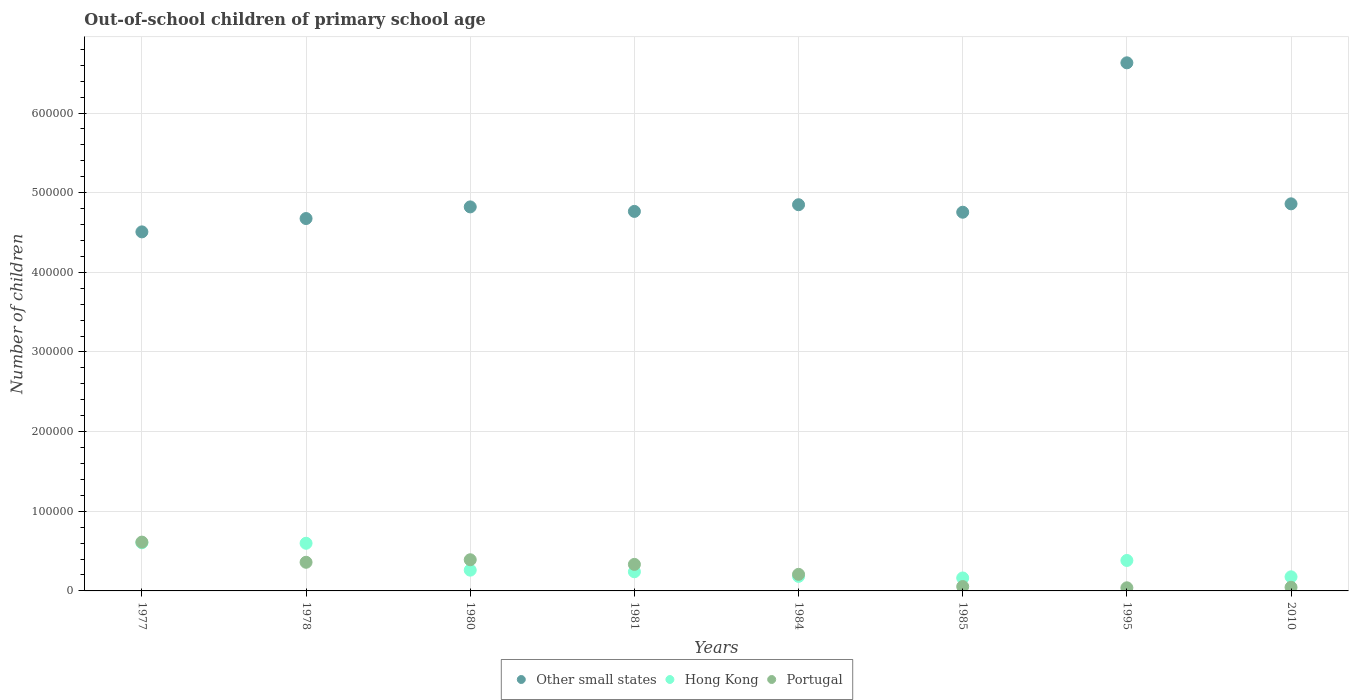What is the number of out-of-school children in Other small states in 1995?
Provide a short and direct response. 6.63e+05. Across all years, what is the maximum number of out-of-school children in Other small states?
Your response must be concise. 6.63e+05. Across all years, what is the minimum number of out-of-school children in Hong Kong?
Keep it short and to the point. 1.63e+04. In which year was the number of out-of-school children in Portugal maximum?
Your answer should be very brief. 1977. In which year was the number of out-of-school children in Hong Kong minimum?
Offer a very short reply. 1985. What is the total number of out-of-school children in Other small states in the graph?
Your answer should be compact. 3.99e+06. What is the difference between the number of out-of-school children in Portugal in 1977 and that in 1995?
Your response must be concise. 5.74e+04. What is the difference between the number of out-of-school children in Other small states in 1984 and the number of out-of-school children in Portugal in 1978?
Your answer should be very brief. 4.49e+05. What is the average number of out-of-school children in Portugal per year?
Provide a succinct answer. 2.56e+04. In the year 1977, what is the difference between the number of out-of-school children in Hong Kong and number of out-of-school children in Other small states?
Your answer should be very brief. -3.90e+05. What is the ratio of the number of out-of-school children in Portugal in 1984 to that in 2010?
Give a very brief answer. 4.57. What is the difference between the highest and the second highest number of out-of-school children in Other small states?
Offer a very short reply. 1.77e+05. What is the difference between the highest and the lowest number of out-of-school children in Other small states?
Ensure brevity in your answer.  2.12e+05. In how many years, is the number of out-of-school children in Other small states greater than the average number of out-of-school children in Other small states taken over all years?
Your response must be concise. 1. Is the sum of the number of out-of-school children in Other small states in 1978 and 1984 greater than the maximum number of out-of-school children in Hong Kong across all years?
Your response must be concise. Yes. Does the number of out-of-school children in Portugal monotonically increase over the years?
Give a very brief answer. No. Is the number of out-of-school children in Portugal strictly greater than the number of out-of-school children in Other small states over the years?
Offer a very short reply. No. Are the values on the major ticks of Y-axis written in scientific E-notation?
Give a very brief answer. No. Does the graph contain any zero values?
Ensure brevity in your answer.  No. Does the graph contain grids?
Your response must be concise. Yes. Where does the legend appear in the graph?
Offer a very short reply. Bottom center. What is the title of the graph?
Keep it short and to the point. Out-of-school children of primary school age. Does "Small states" appear as one of the legend labels in the graph?
Your answer should be very brief. No. What is the label or title of the X-axis?
Ensure brevity in your answer.  Years. What is the label or title of the Y-axis?
Your response must be concise. Number of children. What is the Number of children of Other small states in 1977?
Your answer should be very brief. 4.51e+05. What is the Number of children of Hong Kong in 1977?
Your answer should be very brief. 6.05e+04. What is the Number of children in Portugal in 1977?
Ensure brevity in your answer.  6.13e+04. What is the Number of children of Other small states in 1978?
Give a very brief answer. 4.68e+05. What is the Number of children in Hong Kong in 1978?
Provide a short and direct response. 5.98e+04. What is the Number of children of Portugal in 1978?
Ensure brevity in your answer.  3.60e+04. What is the Number of children in Other small states in 1980?
Your answer should be compact. 4.82e+05. What is the Number of children of Hong Kong in 1980?
Your response must be concise. 2.61e+04. What is the Number of children of Portugal in 1980?
Your response must be concise. 3.91e+04. What is the Number of children in Other small states in 1981?
Your answer should be very brief. 4.77e+05. What is the Number of children of Hong Kong in 1981?
Ensure brevity in your answer.  2.41e+04. What is the Number of children of Portugal in 1981?
Provide a short and direct response. 3.33e+04. What is the Number of children of Other small states in 1984?
Offer a terse response. 4.85e+05. What is the Number of children of Hong Kong in 1984?
Offer a terse response. 1.83e+04. What is the Number of children of Portugal in 1984?
Offer a very short reply. 2.08e+04. What is the Number of children in Other small states in 1985?
Make the answer very short. 4.75e+05. What is the Number of children of Hong Kong in 1985?
Offer a very short reply. 1.63e+04. What is the Number of children in Portugal in 1985?
Your answer should be very brief. 5480. What is the Number of children in Other small states in 1995?
Provide a short and direct response. 6.63e+05. What is the Number of children of Hong Kong in 1995?
Your answer should be compact. 3.82e+04. What is the Number of children of Portugal in 1995?
Make the answer very short. 3909. What is the Number of children of Other small states in 2010?
Your answer should be compact. 4.86e+05. What is the Number of children of Hong Kong in 2010?
Keep it short and to the point. 1.77e+04. What is the Number of children in Portugal in 2010?
Give a very brief answer. 4556. Across all years, what is the maximum Number of children of Other small states?
Ensure brevity in your answer.  6.63e+05. Across all years, what is the maximum Number of children of Hong Kong?
Provide a succinct answer. 6.05e+04. Across all years, what is the maximum Number of children of Portugal?
Provide a succinct answer. 6.13e+04. Across all years, what is the minimum Number of children in Other small states?
Your response must be concise. 4.51e+05. Across all years, what is the minimum Number of children in Hong Kong?
Offer a very short reply. 1.63e+04. Across all years, what is the minimum Number of children in Portugal?
Ensure brevity in your answer.  3909. What is the total Number of children of Other small states in the graph?
Provide a succinct answer. 3.99e+06. What is the total Number of children in Hong Kong in the graph?
Ensure brevity in your answer.  2.61e+05. What is the total Number of children of Portugal in the graph?
Your answer should be compact. 2.04e+05. What is the difference between the Number of children in Other small states in 1977 and that in 1978?
Offer a terse response. -1.68e+04. What is the difference between the Number of children in Hong Kong in 1977 and that in 1978?
Offer a very short reply. 634. What is the difference between the Number of children in Portugal in 1977 and that in 1978?
Your answer should be very brief. 2.53e+04. What is the difference between the Number of children in Other small states in 1977 and that in 1980?
Your answer should be compact. -3.14e+04. What is the difference between the Number of children of Hong Kong in 1977 and that in 1980?
Your answer should be compact. 3.44e+04. What is the difference between the Number of children in Portugal in 1977 and that in 1980?
Provide a short and direct response. 2.21e+04. What is the difference between the Number of children of Other small states in 1977 and that in 1981?
Provide a succinct answer. -2.57e+04. What is the difference between the Number of children in Hong Kong in 1977 and that in 1981?
Provide a short and direct response. 3.64e+04. What is the difference between the Number of children in Portugal in 1977 and that in 1981?
Keep it short and to the point. 2.80e+04. What is the difference between the Number of children in Other small states in 1977 and that in 1984?
Ensure brevity in your answer.  -3.41e+04. What is the difference between the Number of children in Hong Kong in 1977 and that in 1984?
Provide a short and direct response. 4.22e+04. What is the difference between the Number of children of Portugal in 1977 and that in 1984?
Offer a terse response. 4.05e+04. What is the difference between the Number of children in Other small states in 1977 and that in 1985?
Ensure brevity in your answer.  -2.47e+04. What is the difference between the Number of children in Hong Kong in 1977 and that in 1985?
Offer a terse response. 4.42e+04. What is the difference between the Number of children of Portugal in 1977 and that in 1985?
Offer a very short reply. 5.58e+04. What is the difference between the Number of children of Other small states in 1977 and that in 1995?
Provide a succinct answer. -2.12e+05. What is the difference between the Number of children in Hong Kong in 1977 and that in 1995?
Provide a short and direct response. 2.22e+04. What is the difference between the Number of children in Portugal in 1977 and that in 1995?
Ensure brevity in your answer.  5.74e+04. What is the difference between the Number of children of Other small states in 1977 and that in 2010?
Offer a very short reply. -3.52e+04. What is the difference between the Number of children in Hong Kong in 1977 and that in 2010?
Make the answer very short. 4.28e+04. What is the difference between the Number of children of Portugal in 1977 and that in 2010?
Your answer should be very brief. 5.67e+04. What is the difference between the Number of children in Other small states in 1978 and that in 1980?
Keep it short and to the point. -1.46e+04. What is the difference between the Number of children of Hong Kong in 1978 and that in 1980?
Provide a succinct answer. 3.38e+04. What is the difference between the Number of children of Portugal in 1978 and that in 1980?
Give a very brief answer. -3169. What is the difference between the Number of children in Other small states in 1978 and that in 1981?
Make the answer very short. -8960. What is the difference between the Number of children of Hong Kong in 1978 and that in 1981?
Your answer should be very brief. 3.58e+04. What is the difference between the Number of children in Portugal in 1978 and that in 1981?
Your answer should be compact. 2660. What is the difference between the Number of children of Other small states in 1978 and that in 1984?
Provide a short and direct response. -1.73e+04. What is the difference between the Number of children of Hong Kong in 1978 and that in 1984?
Provide a short and direct response. 4.16e+04. What is the difference between the Number of children of Portugal in 1978 and that in 1984?
Make the answer very short. 1.52e+04. What is the difference between the Number of children of Other small states in 1978 and that in 1985?
Your answer should be very brief. -7924. What is the difference between the Number of children of Hong Kong in 1978 and that in 1985?
Your answer should be compact. 4.36e+04. What is the difference between the Number of children in Portugal in 1978 and that in 1985?
Your answer should be compact. 3.05e+04. What is the difference between the Number of children in Other small states in 1978 and that in 1995?
Ensure brevity in your answer.  -1.96e+05. What is the difference between the Number of children of Hong Kong in 1978 and that in 1995?
Offer a terse response. 2.16e+04. What is the difference between the Number of children in Portugal in 1978 and that in 1995?
Your answer should be compact. 3.21e+04. What is the difference between the Number of children of Other small states in 1978 and that in 2010?
Make the answer very short. -1.85e+04. What is the difference between the Number of children of Hong Kong in 1978 and that in 2010?
Offer a very short reply. 4.21e+04. What is the difference between the Number of children of Portugal in 1978 and that in 2010?
Ensure brevity in your answer.  3.14e+04. What is the difference between the Number of children of Other small states in 1980 and that in 1981?
Offer a very short reply. 5654. What is the difference between the Number of children in Hong Kong in 1980 and that in 1981?
Provide a succinct answer. 2023. What is the difference between the Number of children in Portugal in 1980 and that in 1981?
Your answer should be compact. 5829. What is the difference between the Number of children of Other small states in 1980 and that in 1984?
Keep it short and to the point. -2719. What is the difference between the Number of children in Hong Kong in 1980 and that in 1984?
Keep it short and to the point. 7804. What is the difference between the Number of children in Portugal in 1980 and that in 1984?
Offer a terse response. 1.83e+04. What is the difference between the Number of children of Other small states in 1980 and that in 1985?
Your answer should be very brief. 6690. What is the difference between the Number of children of Hong Kong in 1980 and that in 1985?
Your answer should be compact. 9809. What is the difference between the Number of children in Portugal in 1980 and that in 1985?
Your answer should be compact. 3.37e+04. What is the difference between the Number of children in Other small states in 1980 and that in 1995?
Make the answer very short. -1.81e+05. What is the difference between the Number of children in Hong Kong in 1980 and that in 1995?
Keep it short and to the point. -1.22e+04. What is the difference between the Number of children of Portugal in 1980 and that in 1995?
Your answer should be compact. 3.52e+04. What is the difference between the Number of children in Other small states in 1980 and that in 2010?
Offer a terse response. -3837. What is the difference between the Number of children of Hong Kong in 1980 and that in 2010?
Give a very brief answer. 8370. What is the difference between the Number of children of Portugal in 1980 and that in 2010?
Provide a succinct answer. 3.46e+04. What is the difference between the Number of children in Other small states in 1981 and that in 1984?
Offer a terse response. -8373. What is the difference between the Number of children of Hong Kong in 1981 and that in 1984?
Your response must be concise. 5781. What is the difference between the Number of children of Portugal in 1981 and that in 1984?
Your answer should be compact. 1.25e+04. What is the difference between the Number of children in Other small states in 1981 and that in 1985?
Your response must be concise. 1036. What is the difference between the Number of children of Hong Kong in 1981 and that in 1985?
Provide a short and direct response. 7786. What is the difference between the Number of children in Portugal in 1981 and that in 1985?
Provide a short and direct response. 2.78e+04. What is the difference between the Number of children of Other small states in 1981 and that in 1995?
Ensure brevity in your answer.  -1.87e+05. What is the difference between the Number of children of Hong Kong in 1981 and that in 1995?
Offer a terse response. -1.42e+04. What is the difference between the Number of children in Portugal in 1981 and that in 1995?
Provide a succinct answer. 2.94e+04. What is the difference between the Number of children of Other small states in 1981 and that in 2010?
Ensure brevity in your answer.  -9491. What is the difference between the Number of children in Hong Kong in 1981 and that in 2010?
Your response must be concise. 6347. What is the difference between the Number of children of Portugal in 1981 and that in 2010?
Offer a terse response. 2.87e+04. What is the difference between the Number of children in Other small states in 1984 and that in 1985?
Your answer should be very brief. 9409. What is the difference between the Number of children in Hong Kong in 1984 and that in 1985?
Offer a very short reply. 2005. What is the difference between the Number of children in Portugal in 1984 and that in 1985?
Provide a short and direct response. 1.53e+04. What is the difference between the Number of children of Other small states in 1984 and that in 1995?
Provide a short and direct response. -1.78e+05. What is the difference between the Number of children in Hong Kong in 1984 and that in 1995?
Ensure brevity in your answer.  -2.00e+04. What is the difference between the Number of children of Portugal in 1984 and that in 1995?
Provide a succinct answer. 1.69e+04. What is the difference between the Number of children in Other small states in 1984 and that in 2010?
Provide a short and direct response. -1118. What is the difference between the Number of children in Hong Kong in 1984 and that in 2010?
Your response must be concise. 566. What is the difference between the Number of children in Portugal in 1984 and that in 2010?
Ensure brevity in your answer.  1.63e+04. What is the difference between the Number of children in Other small states in 1985 and that in 1995?
Make the answer very short. -1.88e+05. What is the difference between the Number of children in Hong Kong in 1985 and that in 1995?
Ensure brevity in your answer.  -2.20e+04. What is the difference between the Number of children of Portugal in 1985 and that in 1995?
Offer a very short reply. 1571. What is the difference between the Number of children in Other small states in 1985 and that in 2010?
Ensure brevity in your answer.  -1.05e+04. What is the difference between the Number of children of Hong Kong in 1985 and that in 2010?
Provide a succinct answer. -1439. What is the difference between the Number of children in Portugal in 1985 and that in 2010?
Your answer should be very brief. 924. What is the difference between the Number of children of Other small states in 1995 and that in 2010?
Your answer should be very brief. 1.77e+05. What is the difference between the Number of children of Hong Kong in 1995 and that in 2010?
Ensure brevity in your answer.  2.05e+04. What is the difference between the Number of children in Portugal in 1995 and that in 2010?
Your response must be concise. -647. What is the difference between the Number of children of Other small states in 1977 and the Number of children of Hong Kong in 1978?
Keep it short and to the point. 3.91e+05. What is the difference between the Number of children of Other small states in 1977 and the Number of children of Portugal in 1978?
Ensure brevity in your answer.  4.15e+05. What is the difference between the Number of children in Hong Kong in 1977 and the Number of children in Portugal in 1978?
Your answer should be very brief. 2.45e+04. What is the difference between the Number of children in Other small states in 1977 and the Number of children in Hong Kong in 1980?
Ensure brevity in your answer.  4.25e+05. What is the difference between the Number of children in Other small states in 1977 and the Number of children in Portugal in 1980?
Offer a very short reply. 4.12e+05. What is the difference between the Number of children of Hong Kong in 1977 and the Number of children of Portugal in 1980?
Offer a very short reply. 2.13e+04. What is the difference between the Number of children in Other small states in 1977 and the Number of children in Hong Kong in 1981?
Offer a terse response. 4.27e+05. What is the difference between the Number of children of Other small states in 1977 and the Number of children of Portugal in 1981?
Give a very brief answer. 4.17e+05. What is the difference between the Number of children of Hong Kong in 1977 and the Number of children of Portugal in 1981?
Give a very brief answer. 2.72e+04. What is the difference between the Number of children of Other small states in 1977 and the Number of children of Hong Kong in 1984?
Keep it short and to the point. 4.33e+05. What is the difference between the Number of children in Other small states in 1977 and the Number of children in Portugal in 1984?
Make the answer very short. 4.30e+05. What is the difference between the Number of children in Hong Kong in 1977 and the Number of children in Portugal in 1984?
Your answer should be very brief. 3.96e+04. What is the difference between the Number of children in Other small states in 1977 and the Number of children in Hong Kong in 1985?
Offer a terse response. 4.35e+05. What is the difference between the Number of children of Other small states in 1977 and the Number of children of Portugal in 1985?
Give a very brief answer. 4.45e+05. What is the difference between the Number of children in Hong Kong in 1977 and the Number of children in Portugal in 1985?
Make the answer very short. 5.50e+04. What is the difference between the Number of children of Other small states in 1977 and the Number of children of Hong Kong in 1995?
Ensure brevity in your answer.  4.13e+05. What is the difference between the Number of children in Other small states in 1977 and the Number of children in Portugal in 1995?
Give a very brief answer. 4.47e+05. What is the difference between the Number of children in Hong Kong in 1977 and the Number of children in Portugal in 1995?
Your response must be concise. 5.66e+04. What is the difference between the Number of children in Other small states in 1977 and the Number of children in Hong Kong in 2010?
Offer a terse response. 4.33e+05. What is the difference between the Number of children in Other small states in 1977 and the Number of children in Portugal in 2010?
Offer a terse response. 4.46e+05. What is the difference between the Number of children in Hong Kong in 1977 and the Number of children in Portugal in 2010?
Your answer should be compact. 5.59e+04. What is the difference between the Number of children of Other small states in 1978 and the Number of children of Hong Kong in 1980?
Your answer should be compact. 4.41e+05. What is the difference between the Number of children of Other small states in 1978 and the Number of children of Portugal in 1980?
Ensure brevity in your answer.  4.28e+05. What is the difference between the Number of children of Hong Kong in 1978 and the Number of children of Portugal in 1980?
Offer a terse response. 2.07e+04. What is the difference between the Number of children in Other small states in 1978 and the Number of children in Hong Kong in 1981?
Keep it short and to the point. 4.43e+05. What is the difference between the Number of children of Other small states in 1978 and the Number of children of Portugal in 1981?
Keep it short and to the point. 4.34e+05. What is the difference between the Number of children of Hong Kong in 1978 and the Number of children of Portugal in 1981?
Make the answer very short. 2.65e+04. What is the difference between the Number of children in Other small states in 1978 and the Number of children in Hong Kong in 1984?
Your response must be concise. 4.49e+05. What is the difference between the Number of children of Other small states in 1978 and the Number of children of Portugal in 1984?
Make the answer very short. 4.47e+05. What is the difference between the Number of children in Hong Kong in 1978 and the Number of children in Portugal in 1984?
Your response must be concise. 3.90e+04. What is the difference between the Number of children of Other small states in 1978 and the Number of children of Hong Kong in 1985?
Your answer should be very brief. 4.51e+05. What is the difference between the Number of children in Other small states in 1978 and the Number of children in Portugal in 1985?
Provide a succinct answer. 4.62e+05. What is the difference between the Number of children in Hong Kong in 1978 and the Number of children in Portugal in 1985?
Provide a succinct answer. 5.43e+04. What is the difference between the Number of children in Other small states in 1978 and the Number of children in Hong Kong in 1995?
Offer a very short reply. 4.29e+05. What is the difference between the Number of children in Other small states in 1978 and the Number of children in Portugal in 1995?
Offer a terse response. 4.64e+05. What is the difference between the Number of children of Hong Kong in 1978 and the Number of children of Portugal in 1995?
Your answer should be compact. 5.59e+04. What is the difference between the Number of children in Other small states in 1978 and the Number of children in Hong Kong in 2010?
Your response must be concise. 4.50e+05. What is the difference between the Number of children of Other small states in 1978 and the Number of children of Portugal in 2010?
Make the answer very short. 4.63e+05. What is the difference between the Number of children of Hong Kong in 1978 and the Number of children of Portugal in 2010?
Offer a very short reply. 5.53e+04. What is the difference between the Number of children in Other small states in 1980 and the Number of children in Hong Kong in 1981?
Your answer should be very brief. 4.58e+05. What is the difference between the Number of children of Other small states in 1980 and the Number of children of Portugal in 1981?
Your answer should be very brief. 4.49e+05. What is the difference between the Number of children of Hong Kong in 1980 and the Number of children of Portugal in 1981?
Ensure brevity in your answer.  -7230. What is the difference between the Number of children in Other small states in 1980 and the Number of children in Hong Kong in 1984?
Give a very brief answer. 4.64e+05. What is the difference between the Number of children in Other small states in 1980 and the Number of children in Portugal in 1984?
Provide a short and direct response. 4.61e+05. What is the difference between the Number of children in Hong Kong in 1980 and the Number of children in Portugal in 1984?
Provide a succinct answer. 5264. What is the difference between the Number of children of Other small states in 1980 and the Number of children of Hong Kong in 1985?
Offer a terse response. 4.66e+05. What is the difference between the Number of children of Other small states in 1980 and the Number of children of Portugal in 1985?
Ensure brevity in your answer.  4.77e+05. What is the difference between the Number of children in Hong Kong in 1980 and the Number of children in Portugal in 1985?
Provide a succinct answer. 2.06e+04. What is the difference between the Number of children in Other small states in 1980 and the Number of children in Hong Kong in 1995?
Keep it short and to the point. 4.44e+05. What is the difference between the Number of children of Other small states in 1980 and the Number of children of Portugal in 1995?
Give a very brief answer. 4.78e+05. What is the difference between the Number of children of Hong Kong in 1980 and the Number of children of Portugal in 1995?
Offer a terse response. 2.22e+04. What is the difference between the Number of children in Other small states in 1980 and the Number of children in Hong Kong in 2010?
Provide a succinct answer. 4.64e+05. What is the difference between the Number of children of Other small states in 1980 and the Number of children of Portugal in 2010?
Offer a very short reply. 4.78e+05. What is the difference between the Number of children of Hong Kong in 1980 and the Number of children of Portugal in 2010?
Make the answer very short. 2.15e+04. What is the difference between the Number of children in Other small states in 1981 and the Number of children in Hong Kong in 1984?
Provide a short and direct response. 4.58e+05. What is the difference between the Number of children of Other small states in 1981 and the Number of children of Portugal in 1984?
Provide a short and direct response. 4.56e+05. What is the difference between the Number of children in Hong Kong in 1981 and the Number of children in Portugal in 1984?
Your answer should be compact. 3241. What is the difference between the Number of children of Other small states in 1981 and the Number of children of Hong Kong in 1985?
Your answer should be very brief. 4.60e+05. What is the difference between the Number of children in Other small states in 1981 and the Number of children in Portugal in 1985?
Provide a short and direct response. 4.71e+05. What is the difference between the Number of children in Hong Kong in 1981 and the Number of children in Portugal in 1985?
Offer a terse response. 1.86e+04. What is the difference between the Number of children in Other small states in 1981 and the Number of children in Hong Kong in 1995?
Your response must be concise. 4.38e+05. What is the difference between the Number of children of Other small states in 1981 and the Number of children of Portugal in 1995?
Your response must be concise. 4.73e+05. What is the difference between the Number of children in Hong Kong in 1981 and the Number of children in Portugal in 1995?
Make the answer very short. 2.01e+04. What is the difference between the Number of children in Other small states in 1981 and the Number of children in Hong Kong in 2010?
Make the answer very short. 4.59e+05. What is the difference between the Number of children in Other small states in 1981 and the Number of children in Portugal in 2010?
Your answer should be compact. 4.72e+05. What is the difference between the Number of children in Hong Kong in 1981 and the Number of children in Portugal in 2010?
Your answer should be compact. 1.95e+04. What is the difference between the Number of children of Other small states in 1984 and the Number of children of Hong Kong in 1985?
Your response must be concise. 4.69e+05. What is the difference between the Number of children of Other small states in 1984 and the Number of children of Portugal in 1985?
Ensure brevity in your answer.  4.79e+05. What is the difference between the Number of children in Hong Kong in 1984 and the Number of children in Portugal in 1985?
Keep it short and to the point. 1.28e+04. What is the difference between the Number of children of Other small states in 1984 and the Number of children of Hong Kong in 1995?
Provide a short and direct response. 4.47e+05. What is the difference between the Number of children in Other small states in 1984 and the Number of children in Portugal in 1995?
Provide a succinct answer. 4.81e+05. What is the difference between the Number of children of Hong Kong in 1984 and the Number of children of Portugal in 1995?
Provide a succinct answer. 1.44e+04. What is the difference between the Number of children in Other small states in 1984 and the Number of children in Hong Kong in 2010?
Your answer should be compact. 4.67e+05. What is the difference between the Number of children of Other small states in 1984 and the Number of children of Portugal in 2010?
Keep it short and to the point. 4.80e+05. What is the difference between the Number of children in Hong Kong in 1984 and the Number of children in Portugal in 2010?
Keep it short and to the point. 1.37e+04. What is the difference between the Number of children of Other small states in 1985 and the Number of children of Hong Kong in 1995?
Your answer should be compact. 4.37e+05. What is the difference between the Number of children of Other small states in 1985 and the Number of children of Portugal in 1995?
Make the answer very short. 4.72e+05. What is the difference between the Number of children in Hong Kong in 1985 and the Number of children in Portugal in 1995?
Provide a short and direct response. 1.24e+04. What is the difference between the Number of children in Other small states in 1985 and the Number of children in Hong Kong in 2010?
Offer a very short reply. 4.58e+05. What is the difference between the Number of children of Other small states in 1985 and the Number of children of Portugal in 2010?
Make the answer very short. 4.71e+05. What is the difference between the Number of children of Hong Kong in 1985 and the Number of children of Portugal in 2010?
Your answer should be compact. 1.17e+04. What is the difference between the Number of children in Other small states in 1995 and the Number of children in Hong Kong in 2010?
Provide a succinct answer. 6.45e+05. What is the difference between the Number of children in Other small states in 1995 and the Number of children in Portugal in 2010?
Provide a short and direct response. 6.58e+05. What is the difference between the Number of children of Hong Kong in 1995 and the Number of children of Portugal in 2010?
Your answer should be very brief. 3.37e+04. What is the average Number of children in Other small states per year?
Offer a terse response. 4.98e+05. What is the average Number of children in Hong Kong per year?
Your response must be concise. 3.26e+04. What is the average Number of children of Portugal per year?
Make the answer very short. 2.56e+04. In the year 1977, what is the difference between the Number of children of Other small states and Number of children of Hong Kong?
Ensure brevity in your answer.  3.90e+05. In the year 1977, what is the difference between the Number of children of Other small states and Number of children of Portugal?
Ensure brevity in your answer.  3.90e+05. In the year 1977, what is the difference between the Number of children of Hong Kong and Number of children of Portugal?
Your answer should be compact. -816. In the year 1978, what is the difference between the Number of children of Other small states and Number of children of Hong Kong?
Offer a very short reply. 4.08e+05. In the year 1978, what is the difference between the Number of children of Other small states and Number of children of Portugal?
Provide a short and direct response. 4.32e+05. In the year 1978, what is the difference between the Number of children of Hong Kong and Number of children of Portugal?
Offer a terse response. 2.39e+04. In the year 1980, what is the difference between the Number of children in Other small states and Number of children in Hong Kong?
Ensure brevity in your answer.  4.56e+05. In the year 1980, what is the difference between the Number of children in Other small states and Number of children in Portugal?
Provide a succinct answer. 4.43e+05. In the year 1980, what is the difference between the Number of children in Hong Kong and Number of children in Portugal?
Ensure brevity in your answer.  -1.31e+04. In the year 1981, what is the difference between the Number of children of Other small states and Number of children of Hong Kong?
Ensure brevity in your answer.  4.52e+05. In the year 1981, what is the difference between the Number of children in Other small states and Number of children in Portugal?
Offer a terse response. 4.43e+05. In the year 1981, what is the difference between the Number of children in Hong Kong and Number of children in Portugal?
Provide a short and direct response. -9253. In the year 1984, what is the difference between the Number of children in Other small states and Number of children in Hong Kong?
Offer a terse response. 4.67e+05. In the year 1984, what is the difference between the Number of children in Other small states and Number of children in Portugal?
Provide a succinct answer. 4.64e+05. In the year 1984, what is the difference between the Number of children of Hong Kong and Number of children of Portugal?
Ensure brevity in your answer.  -2540. In the year 1985, what is the difference between the Number of children of Other small states and Number of children of Hong Kong?
Offer a terse response. 4.59e+05. In the year 1985, what is the difference between the Number of children of Other small states and Number of children of Portugal?
Give a very brief answer. 4.70e+05. In the year 1985, what is the difference between the Number of children of Hong Kong and Number of children of Portugal?
Make the answer very short. 1.08e+04. In the year 1995, what is the difference between the Number of children in Other small states and Number of children in Hong Kong?
Ensure brevity in your answer.  6.25e+05. In the year 1995, what is the difference between the Number of children of Other small states and Number of children of Portugal?
Ensure brevity in your answer.  6.59e+05. In the year 1995, what is the difference between the Number of children in Hong Kong and Number of children in Portugal?
Provide a short and direct response. 3.43e+04. In the year 2010, what is the difference between the Number of children of Other small states and Number of children of Hong Kong?
Offer a very short reply. 4.68e+05. In the year 2010, what is the difference between the Number of children in Other small states and Number of children in Portugal?
Your answer should be very brief. 4.81e+05. In the year 2010, what is the difference between the Number of children in Hong Kong and Number of children in Portugal?
Give a very brief answer. 1.31e+04. What is the ratio of the Number of children in Other small states in 1977 to that in 1978?
Provide a short and direct response. 0.96. What is the ratio of the Number of children in Hong Kong in 1977 to that in 1978?
Ensure brevity in your answer.  1.01. What is the ratio of the Number of children of Portugal in 1977 to that in 1978?
Your answer should be very brief. 1.7. What is the ratio of the Number of children of Other small states in 1977 to that in 1980?
Your answer should be compact. 0.94. What is the ratio of the Number of children in Hong Kong in 1977 to that in 1980?
Your answer should be compact. 2.32. What is the ratio of the Number of children in Portugal in 1977 to that in 1980?
Make the answer very short. 1.57. What is the ratio of the Number of children of Other small states in 1977 to that in 1981?
Provide a short and direct response. 0.95. What is the ratio of the Number of children in Hong Kong in 1977 to that in 1981?
Ensure brevity in your answer.  2.51. What is the ratio of the Number of children of Portugal in 1977 to that in 1981?
Your answer should be compact. 1.84. What is the ratio of the Number of children in Other small states in 1977 to that in 1984?
Your answer should be very brief. 0.93. What is the ratio of the Number of children in Hong Kong in 1977 to that in 1984?
Make the answer very short. 3.31. What is the ratio of the Number of children in Portugal in 1977 to that in 1984?
Offer a very short reply. 2.94. What is the ratio of the Number of children of Other small states in 1977 to that in 1985?
Your answer should be very brief. 0.95. What is the ratio of the Number of children of Hong Kong in 1977 to that in 1985?
Make the answer very short. 3.72. What is the ratio of the Number of children in Portugal in 1977 to that in 1985?
Your answer should be very brief. 11.18. What is the ratio of the Number of children of Other small states in 1977 to that in 1995?
Give a very brief answer. 0.68. What is the ratio of the Number of children in Hong Kong in 1977 to that in 1995?
Your answer should be compact. 1.58. What is the ratio of the Number of children in Portugal in 1977 to that in 1995?
Make the answer very short. 15.68. What is the ratio of the Number of children of Other small states in 1977 to that in 2010?
Give a very brief answer. 0.93. What is the ratio of the Number of children of Hong Kong in 1977 to that in 2010?
Your answer should be very brief. 3.42. What is the ratio of the Number of children in Portugal in 1977 to that in 2010?
Offer a terse response. 13.45. What is the ratio of the Number of children in Other small states in 1978 to that in 1980?
Offer a very short reply. 0.97. What is the ratio of the Number of children in Hong Kong in 1978 to that in 1980?
Your answer should be compact. 2.29. What is the ratio of the Number of children of Portugal in 1978 to that in 1980?
Provide a succinct answer. 0.92. What is the ratio of the Number of children in Other small states in 1978 to that in 1981?
Keep it short and to the point. 0.98. What is the ratio of the Number of children of Hong Kong in 1978 to that in 1981?
Your answer should be very brief. 2.49. What is the ratio of the Number of children of Portugal in 1978 to that in 1981?
Your answer should be very brief. 1.08. What is the ratio of the Number of children of Other small states in 1978 to that in 1984?
Your answer should be very brief. 0.96. What is the ratio of the Number of children of Hong Kong in 1978 to that in 1984?
Keep it short and to the point. 3.27. What is the ratio of the Number of children in Portugal in 1978 to that in 1984?
Keep it short and to the point. 1.73. What is the ratio of the Number of children in Other small states in 1978 to that in 1985?
Provide a short and direct response. 0.98. What is the ratio of the Number of children in Hong Kong in 1978 to that in 1985?
Provide a short and direct response. 3.68. What is the ratio of the Number of children in Portugal in 1978 to that in 1985?
Offer a terse response. 6.56. What is the ratio of the Number of children in Other small states in 1978 to that in 1995?
Provide a succinct answer. 0.71. What is the ratio of the Number of children of Hong Kong in 1978 to that in 1995?
Ensure brevity in your answer.  1.56. What is the ratio of the Number of children in Portugal in 1978 to that in 1995?
Your answer should be compact. 9.2. What is the ratio of the Number of children of Hong Kong in 1978 to that in 2010?
Give a very brief answer. 3.38. What is the ratio of the Number of children in Portugal in 1978 to that in 2010?
Provide a short and direct response. 7.89. What is the ratio of the Number of children of Other small states in 1980 to that in 1981?
Keep it short and to the point. 1.01. What is the ratio of the Number of children in Hong Kong in 1980 to that in 1981?
Your answer should be compact. 1.08. What is the ratio of the Number of children of Portugal in 1980 to that in 1981?
Your answer should be compact. 1.18. What is the ratio of the Number of children of Other small states in 1980 to that in 1984?
Offer a very short reply. 0.99. What is the ratio of the Number of children of Hong Kong in 1980 to that in 1984?
Ensure brevity in your answer.  1.43. What is the ratio of the Number of children in Portugal in 1980 to that in 1984?
Your response must be concise. 1.88. What is the ratio of the Number of children in Other small states in 1980 to that in 1985?
Your response must be concise. 1.01. What is the ratio of the Number of children in Hong Kong in 1980 to that in 1985?
Ensure brevity in your answer.  1.6. What is the ratio of the Number of children of Portugal in 1980 to that in 1985?
Make the answer very short. 7.14. What is the ratio of the Number of children of Other small states in 1980 to that in 1995?
Give a very brief answer. 0.73. What is the ratio of the Number of children in Hong Kong in 1980 to that in 1995?
Your response must be concise. 0.68. What is the ratio of the Number of children in Portugal in 1980 to that in 1995?
Your answer should be compact. 10.01. What is the ratio of the Number of children of Other small states in 1980 to that in 2010?
Provide a short and direct response. 0.99. What is the ratio of the Number of children of Hong Kong in 1980 to that in 2010?
Your answer should be very brief. 1.47. What is the ratio of the Number of children of Portugal in 1980 to that in 2010?
Your response must be concise. 8.59. What is the ratio of the Number of children in Other small states in 1981 to that in 1984?
Your answer should be very brief. 0.98. What is the ratio of the Number of children of Hong Kong in 1981 to that in 1984?
Your response must be concise. 1.32. What is the ratio of the Number of children of Portugal in 1981 to that in 1984?
Your response must be concise. 1.6. What is the ratio of the Number of children of Other small states in 1981 to that in 1985?
Offer a very short reply. 1. What is the ratio of the Number of children in Hong Kong in 1981 to that in 1985?
Provide a short and direct response. 1.48. What is the ratio of the Number of children in Portugal in 1981 to that in 1985?
Provide a short and direct response. 6.08. What is the ratio of the Number of children of Other small states in 1981 to that in 1995?
Your response must be concise. 0.72. What is the ratio of the Number of children of Hong Kong in 1981 to that in 1995?
Offer a very short reply. 0.63. What is the ratio of the Number of children in Portugal in 1981 to that in 1995?
Make the answer very short. 8.52. What is the ratio of the Number of children of Other small states in 1981 to that in 2010?
Offer a very short reply. 0.98. What is the ratio of the Number of children of Hong Kong in 1981 to that in 2010?
Provide a succinct answer. 1.36. What is the ratio of the Number of children in Portugal in 1981 to that in 2010?
Keep it short and to the point. 7.31. What is the ratio of the Number of children in Other small states in 1984 to that in 1985?
Provide a succinct answer. 1.02. What is the ratio of the Number of children in Hong Kong in 1984 to that in 1985?
Give a very brief answer. 1.12. What is the ratio of the Number of children in Portugal in 1984 to that in 1985?
Provide a short and direct response. 3.8. What is the ratio of the Number of children of Other small states in 1984 to that in 1995?
Ensure brevity in your answer.  0.73. What is the ratio of the Number of children in Hong Kong in 1984 to that in 1995?
Make the answer very short. 0.48. What is the ratio of the Number of children of Portugal in 1984 to that in 1995?
Your response must be concise. 5.32. What is the ratio of the Number of children in Hong Kong in 1984 to that in 2010?
Offer a terse response. 1.03. What is the ratio of the Number of children of Portugal in 1984 to that in 2010?
Make the answer very short. 4.57. What is the ratio of the Number of children in Other small states in 1985 to that in 1995?
Offer a very short reply. 0.72. What is the ratio of the Number of children in Hong Kong in 1985 to that in 1995?
Offer a terse response. 0.43. What is the ratio of the Number of children of Portugal in 1985 to that in 1995?
Ensure brevity in your answer.  1.4. What is the ratio of the Number of children of Other small states in 1985 to that in 2010?
Ensure brevity in your answer.  0.98. What is the ratio of the Number of children of Hong Kong in 1985 to that in 2010?
Provide a succinct answer. 0.92. What is the ratio of the Number of children of Portugal in 1985 to that in 2010?
Make the answer very short. 1.2. What is the ratio of the Number of children of Other small states in 1995 to that in 2010?
Your response must be concise. 1.36. What is the ratio of the Number of children of Hong Kong in 1995 to that in 2010?
Your answer should be very brief. 2.16. What is the ratio of the Number of children of Portugal in 1995 to that in 2010?
Provide a short and direct response. 0.86. What is the difference between the highest and the second highest Number of children in Other small states?
Your answer should be very brief. 1.77e+05. What is the difference between the highest and the second highest Number of children in Hong Kong?
Your response must be concise. 634. What is the difference between the highest and the second highest Number of children of Portugal?
Provide a short and direct response. 2.21e+04. What is the difference between the highest and the lowest Number of children of Other small states?
Provide a succinct answer. 2.12e+05. What is the difference between the highest and the lowest Number of children in Hong Kong?
Keep it short and to the point. 4.42e+04. What is the difference between the highest and the lowest Number of children in Portugal?
Ensure brevity in your answer.  5.74e+04. 